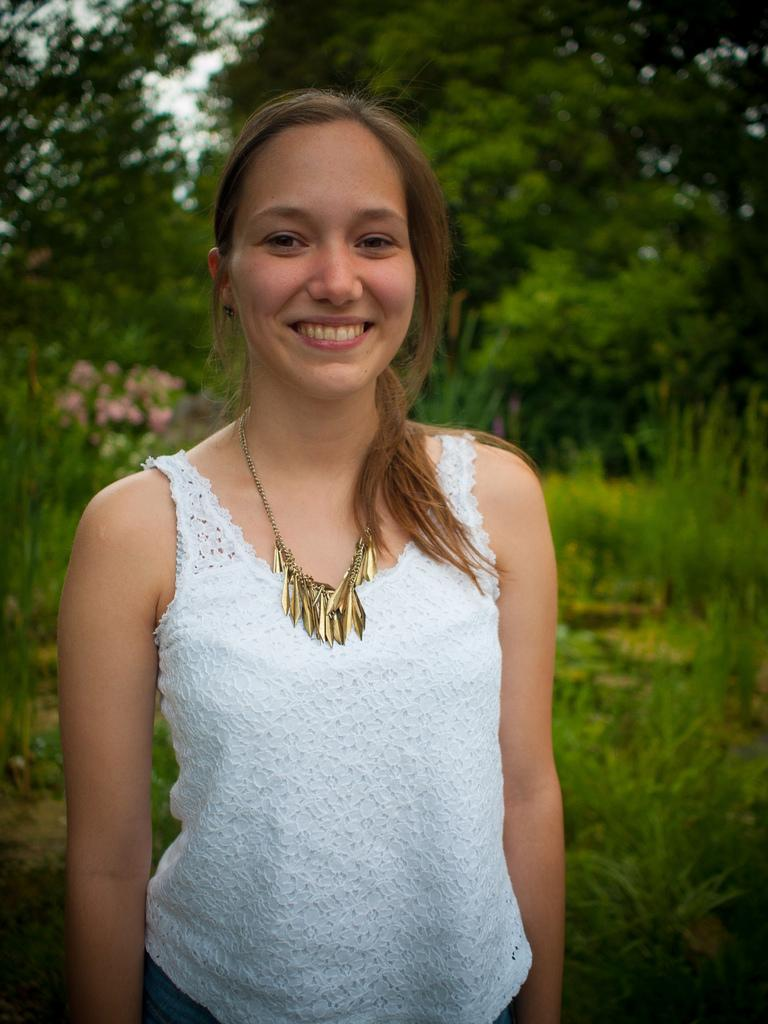What is the main subject of the image? There is a person in the image. What is the person doing in the image? The person is smiling in the image. What is visible in the background of the image? The person is standing in front of trees in the image. What is the person wearing in the image? The person is wearing clothes in the image. How many ducks are visible in the image? There are no ducks present in the image. What type of wren can be seen perched on the person's shoulder in the image? There is no wren present in the image. 